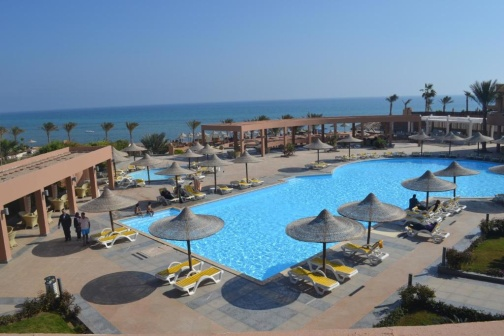If this resort were a setting in a fantasy novel, what kind of adventures might take place here? In a fantasy novel, this resort might be a sanctuary for adventurers returning from their quests. By day, the poolside serves as a place for heroes to relax and recount their stories. At night, the resort transforms under the moonlight; the waters of the pool reveal an ancient, magical map that leads to hidden treasures beneath the ocean. Secret portals disguised as ordinary doors in the pink building might lead to mysterious realms. The palm trees whisper legends of mythical creatures, and the horizon holds secrets of distant lands and ancient artifacts waiting to be discovered.  Envision a short scene where someone makes an extraordinary discovery at this resort. As the sun sets, casting golden hues across the resort, a young traveler named Elara lounges by the pool, idly tracing patterns in the water. Her fingers brush against something peculiar. Diving in, she retrieves a small, intricately carved box. Curiosity piqued, she opens it to find an old compass, which begins to glow and point towards the ocean. Intrigued, Elara follows the compass's direction to the beach, where it leads her to an ancient, coral-encrusted doorway partially hidden in the sand. She pushes the door open to reveal a staircase spiraling into an underwater cavern, shimmering with the glow of bioluminescent flora. The discovery marks the beginning of an epic underwater adventure as Elara explores the secrets of a long-lost civilization.  How would a family spend their perfect day at this resort? A family begins their perfect day with an early morning swim in the pool, the children splashing joyfully while parents lounge nearby with a morning coffee. After breakfast, they build sandcastles on the beach, followed by a game of frisbee. The noon sun leads them back to the resort for lunch under the shade of the open-air structure. The afternoon is spent exploring nearby attractions or engaging in family-friendly activities like snorkeling or paddleboarding. As evening falls, they gather for a sunset dinner, laughter echoing as they share stories of the day. The night ends with stargazing by the pool, the children drifting off to sleep on the lounge chairs as the parents enjoy a final, peaceful moment together. What might be a typical interaction between two resort guests? Guest 1: "Good morning! Beautiful day, isn't it?"
Guest 2: "Absolutely! I was just thinking of taking a dip in the pool."
Guest 1: "sharegpt4v/same here. It's so refreshing, especially with this weather. Have you tried the breakfast here yet?"
Guest 2: "Yes, and it's amazing. They have a great selection of fresh fruits and pastries."
Guest 1: "Sounds delicious! I might head there after my swim. Any plans for exploring today?"
Guest 2: "I’m thinking about checking out the coral reef nearby. I heard it's fantastic for snorkeling."
Guest 1: "That sounds incredible. I might join you!"
The guests then share their plans and excitement, enjoying each other's company as they bask in the leisurely resort atmosphere. 